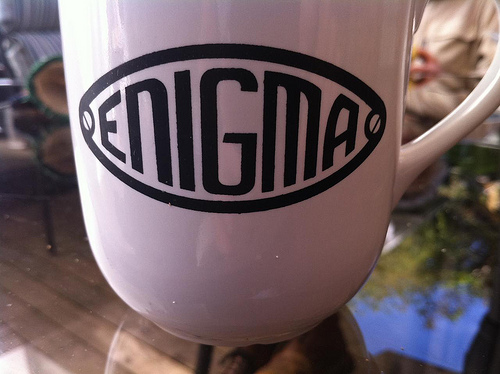<image>
Can you confirm if the logo is above the mug? Yes. The logo is positioned above the mug in the vertical space, higher up in the scene. 